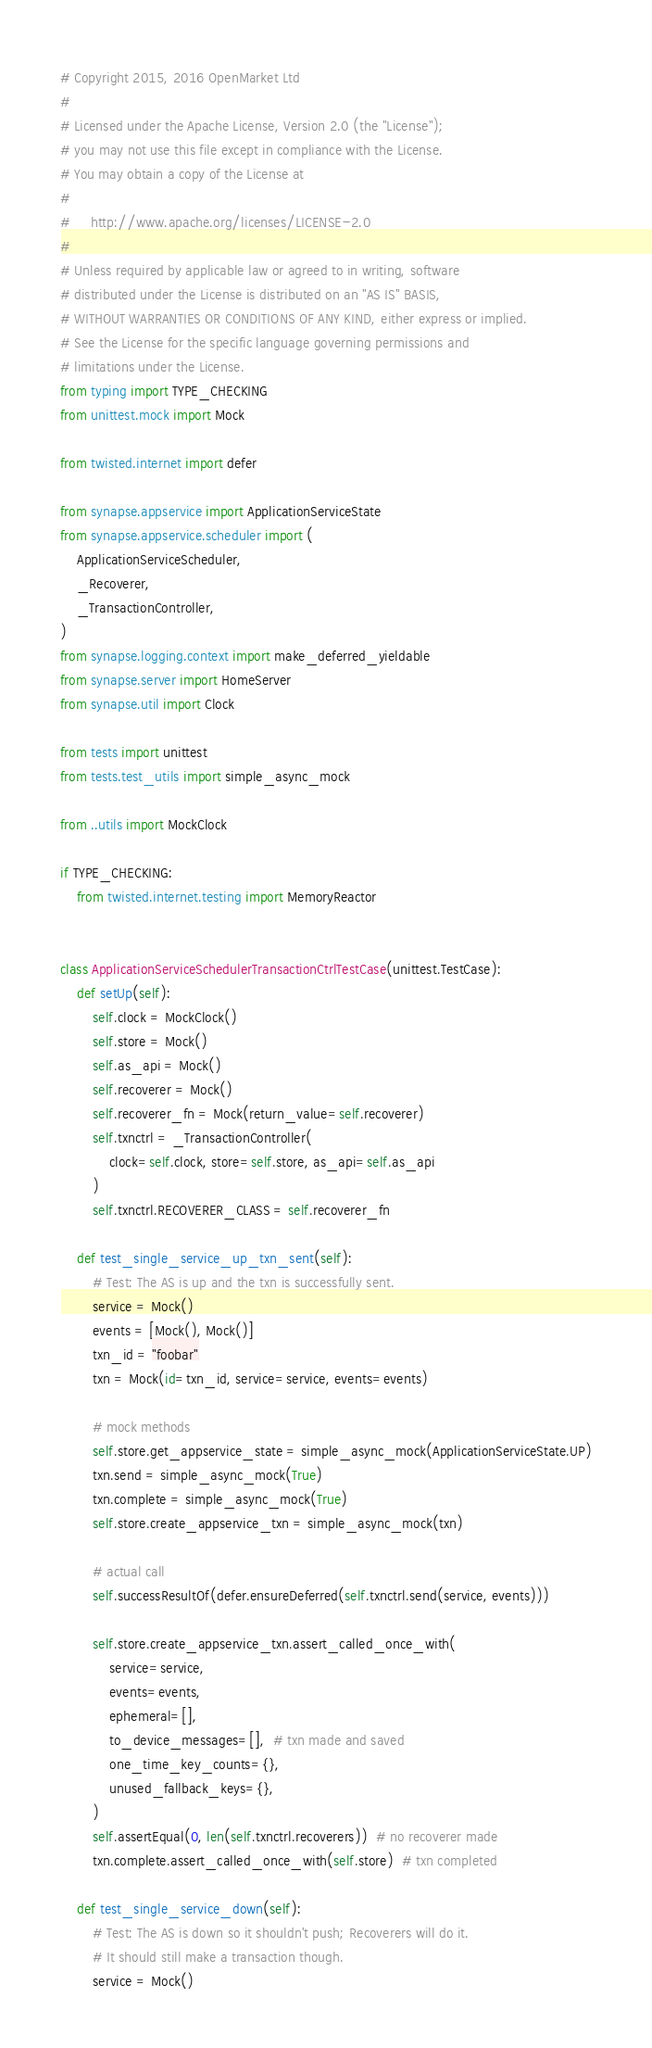<code> <loc_0><loc_0><loc_500><loc_500><_Python_># Copyright 2015, 2016 OpenMarket Ltd
#
# Licensed under the Apache License, Version 2.0 (the "License");
# you may not use this file except in compliance with the License.
# You may obtain a copy of the License at
#
#     http://www.apache.org/licenses/LICENSE-2.0
#
# Unless required by applicable law or agreed to in writing, software
# distributed under the License is distributed on an "AS IS" BASIS,
# WITHOUT WARRANTIES OR CONDITIONS OF ANY KIND, either express or implied.
# See the License for the specific language governing permissions and
# limitations under the License.
from typing import TYPE_CHECKING
from unittest.mock import Mock

from twisted.internet import defer

from synapse.appservice import ApplicationServiceState
from synapse.appservice.scheduler import (
    ApplicationServiceScheduler,
    _Recoverer,
    _TransactionController,
)
from synapse.logging.context import make_deferred_yieldable
from synapse.server import HomeServer
from synapse.util import Clock

from tests import unittest
from tests.test_utils import simple_async_mock

from ..utils import MockClock

if TYPE_CHECKING:
    from twisted.internet.testing import MemoryReactor


class ApplicationServiceSchedulerTransactionCtrlTestCase(unittest.TestCase):
    def setUp(self):
        self.clock = MockClock()
        self.store = Mock()
        self.as_api = Mock()
        self.recoverer = Mock()
        self.recoverer_fn = Mock(return_value=self.recoverer)
        self.txnctrl = _TransactionController(
            clock=self.clock, store=self.store, as_api=self.as_api
        )
        self.txnctrl.RECOVERER_CLASS = self.recoverer_fn

    def test_single_service_up_txn_sent(self):
        # Test: The AS is up and the txn is successfully sent.
        service = Mock()
        events = [Mock(), Mock()]
        txn_id = "foobar"
        txn = Mock(id=txn_id, service=service, events=events)

        # mock methods
        self.store.get_appservice_state = simple_async_mock(ApplicationServiceState.UP)
        txn.send = simple_async_mock(True)
        txn.complete = simple_async_mock(True)
        self.store.create_appservice_txn = simple_async_mock(txn)

        # actual call
        self.successResultOf(defer.ensureDeferred(self.txnctrl.send(service, events)))

        self.store.create_appservice_txn.assert_called_once_with(
            service=service,
            events=events,
            ephemeral=[],
            to_device_messages=[],  # txn made and saved
            one_time_key_counts={},
            unused_fallback_keys={},
        )
        self.assertEqual(0, len(self.txnctrl.recoverers))  # no recoverer made
        txn.complete.assert_called_once_with(self.store)  # txn completed

    def test_single_service_down(self):
        # Test: The AS is down so it shouldn't push; Recoverers will do it.
        # It should still make a transaction though.
        service = Mock()</code> 